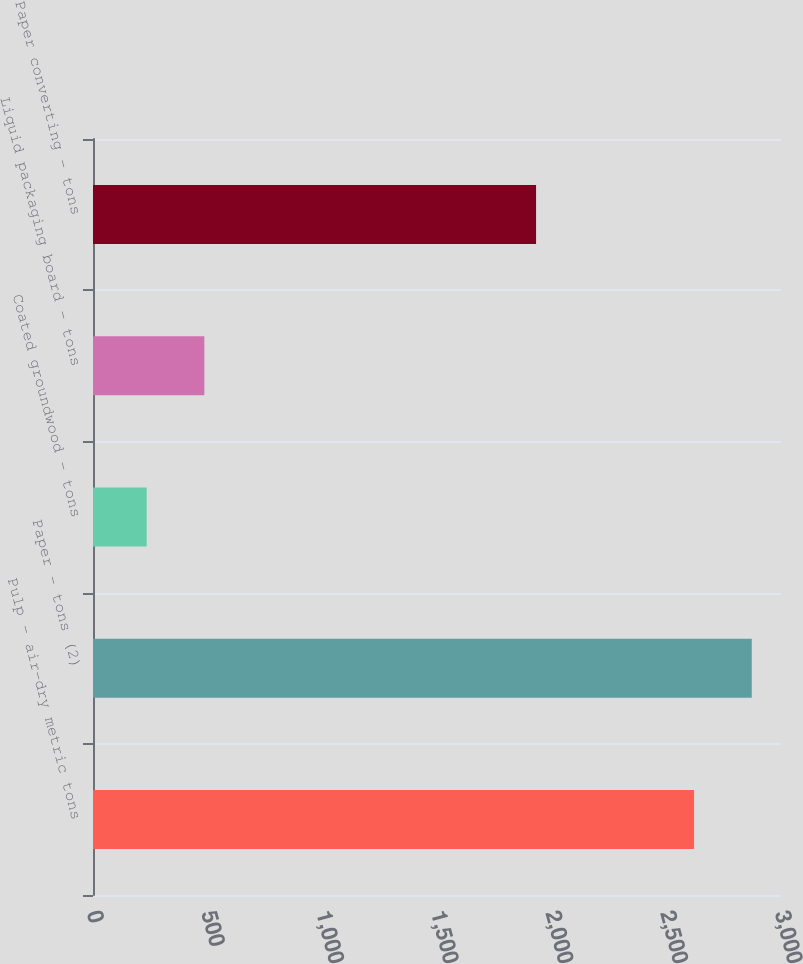Convert chart. <chart><loc_0><loc_0><loc_500><loc_500><bar_chart><fcel>Pulp - air-dry metric tons<fcel>Paper - tons (2)<fcel>Coated groundwood - tons<fcel>Liquid packaging board - tons<fcel>Paper converting - tons<nl><fcel>2621<fcel>2872.5<fcel>234<fcel>485.5<fcel>1932<nl></chart> 